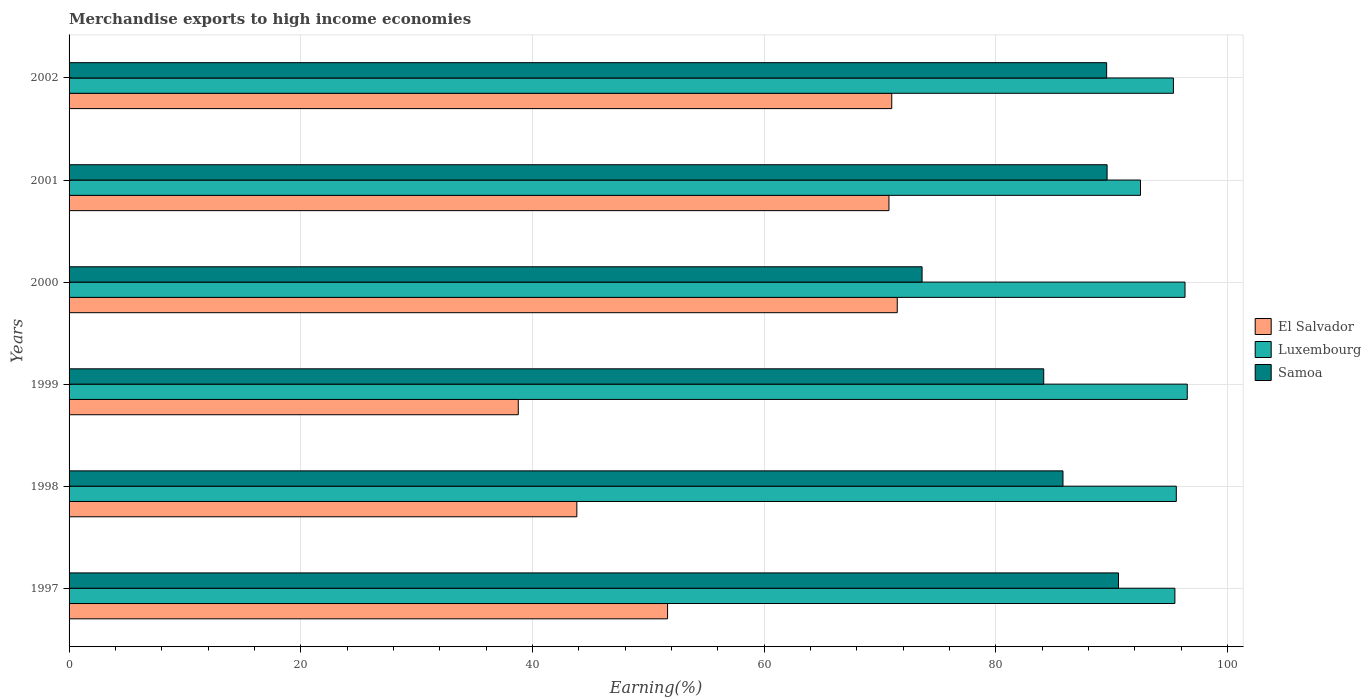How many different coloured bars are there?
Give a very brief answer. 3. How many groups of bars are there?
Your answer should be very brief. 6. Are the number of bars per tick equal to the number of legend labels?
Ensure brevity in your answer.  Yes. How many bars are there on the 3rd tick from the top?
Ensure brevity in your answer.  3. How many bars are there on the 3rd tick from the bottom?
Your answer should be compact. 3. In how many cases, is the number of bars for a given year not equal to the number of legend labels?
Ensure brevity in your answer.  0. What is the percentage of amount earned from merchandise exports in El Salvador in 2001?
Keep it short and to the point. 70.76. Across all years, what is the maximum percentage of amount earned from merchandise exports in Samoa?
Your answer should be very brief. 90.58. Across all years, what is the minimum percentage of amount earned from merchandise exports in Samoa?
Offer a terse response. 73.62. What is the total percentage of amount earned from merchandise exports in Luxembourg in the graph?
Your answer should be compact. 571.63. What is the difference between the percentage of amount earned from merchandise exports in Samoa in 2000 and that in 2001?
Offer a terse response. -15.97. What is the difference between the percentage of amount earned from merchandise exports in Luxembourg in 1998 and the percentage of amount earned from merchandise exports in El Salvador in 2001?
Ensure brevity in your answer.  24.8. What is the average percentage of amount earned from merchandise exports in El Salvador per year?
Offer a very short reply. 57.92. In the year 2001, what is the difference between the percentage of amount earned from merchandise exports in Samoa and percentage of amount earned from merchandise exports in El Salvador?
Offer a terse response. 18.83. In how many years, is the percentage of amount earned from merchandise exports in Luxembourg greater than 76 %?
Ensure brevity in your answer.  6. What is the ratio of the percentage of amount earned from merchandise exports in El Salvador in 1997 to that in 2000?
Provide a short and direct response. 0.72. Is the percentage of amount earned from merchandise exports in El Salvador in 2001 less than that in 2002?
Give a very brief answer. Yes. What is the difference between the highest and the second highest percentage of amount earned from merchandise exports in Samoa?
Ensure brevity in your answer.  0.98. What is the difference between the highest and the lowest percentage of amount earned from merchandise exports in Samoa?
Your answer should be compact. 16.95. In how many years, is the percentage of amount earned from merchandise exports in Luxembourg greater than the average percentage of amount earned from merchandise exports in Luxembourg taken over all years?
Offer a very short reply. 5. Is the sum of the percentage of amount earned from merchandise exports in Luxembourg in 1998 and 1999 greater than the maximum percentage of amount earned from merchandise exports in El Salvador across all years?
Give a very brief answer. Yes. What does the 1st bar from the top in 1999 represents?
Your answer should be compact. Samoa. What does the 1st bar from the bottom in 2000 represents?
Offer a very short reply. El Salvador. Is it the case that in every year, the sum of the percentage of amount earned from merchandise exports in Luxembourg and percentage of amount earned from merchandise exports in El Salvador is greater than the percentage of amount earned from merchandise exports in Samoa?
Your answer should be compact. Yes. How many bars are there?
Offer a very short reply. 18. How many years are there in the graph?
Give a very brief answer. 6. What is the difference between two consecutive major ticks on the X-axis?
Your answer should be compact. 20. Where does the legend appear in the graph?
Provide a succinct answer. Center right. How are the legend labels stacked?
Ensure brevity in your answer.  Vertical. What is the title of the graph?
Make the answer very short. Merchandise exports to high income economies. Does "Montenegro" appear as one of the legend labels in the graph?
Give a very brief answer. No. What is the label or title of the X-axis?
Offer a terse response. Earning(%). What is the Earning(%) of El Salvador in 1997?
Offer a very short reply. 51.66. What is the Earning(%) of Luxembourg in 1997?
Your response must be concise. 95.44. What is the Earning(%) of Samoa in 1997?
Give a very brief answer. 90.58. What is the Earning(%) in El Salvador in 1998?
Ensure brevity in your answer.  43.83. What is the Earning(%) of Luxembourg in 1998?
Ensure brevity in your answer.  95.57. What is the Earning(%) of Samoa in 1998?
Make the answer very short. 85.79. What is the Earning(%) of El Salvador in 1999?
Offer a terse response. 38.77. What is the Earning(%) of Luxembourg in 1999?
Provide a short and direct response. 96.51. What is the Earning(%) in Samoa in 1999?
Your response must be concise. 84.12. What is the Earning(%) of El Salvador in 2000?
Ensure brevity in your answer.  71.48. What is the Earning(%) in Luxembourg in 2000?
Your answer should be compact. 96.32. What is the Earning(%) in Samoa in 2000?
Ensure brevity in your answer.  73.62. What is the Earning(%) of El Salvador in 2001?
Provide a succinct answer. 70.76. What is the Earning(%) of Luxembourg in 2001?
Your answer should be very brief. 92.48. What is the Earning(%) of Samoa in 2001?
Provide a succinct answer. 89.59. What is the Earning(%) of El Salvador in 2002?
Ensure brevity in your answer.  71.01. What is the Earning(%) in Luxembourg in 2002?
Ensure brevity in your answer.  95.32. What is the Earning(%) of Samoa in 2002?
Give a very brief answer. 89.55. Across all years, what is the maximum Earning(%) of El Salvador?
Provide a succinct answer. 71.48. Across all years, what is the maximum Earning(%) of Luxembourg?
Keep it short and to the point. 96.51. Across all years, what is the maximum Earning(%) of Samoa?
Keep it short and to the point. 90.58. Across all years, what is the minimum Earning(%) of El Salvador?
Ensure brevity in your answer.  38.77. Across all years, what is the minimum Earning(%) in Luxembourg?
Provide a succinct answer. 92.48. Across all years, what is the minimum Earning(%) of Samoa?
Your answer should be very brief. 73.62. What is the total Earning(%) of El Salvador in the graph?
Provide a short and direct response. 347.51. What is the total Earning(%) in Luxembourg in the graph?
Your answer should be very brief. 571.63. What is the total Earning(%) of Samoa in the graph?
Your answer should be compact. 513.25. What is the difference between the Earning(%) in El Salvador in 1997 and that in 1998?
Give a very brief answer. 7.83. What is the difference between the Earning(%) in Luxembourg in 1997 and that in 1998?
Ensure brevity in your answer.  -0.12. What is the difference between the Earning(%) in Samoa in 1997 and that in 1998?
Make the answer very short. 4.79. What is the difference between the Earning(%) in El Salvador in 1997 and that in 1999?
Your answer should be compact. 12.89. What is the difference between the Earning(%) in Luxembourg in 1997 and that in 1999?
Offer a very short reply. -1.07. What is the difference between the Earning(%) in Samoa in 1997 and that in 1999?
Keep it short and to the point. 6.45. What is the difference between the Earning(%) in El Salvador in 1997 and that in 2000?
Give a very brief answer. -19.82. What is the difference between the Earning(%) in Luxembourg in 1997 and that in 2000?
Your response must be concise. -0.87. What is the difference between the Earning(%) in Samoa in 1997 and that in 2000?
Keep it short and to the point. 16.95. What is the difference between the Earning(%) of El Salvador in 1997 and that in 2001?
Provide a short and direct response. -19.11. What is the difference between the Earning(%) of Luxembourg in 1997 and that in 2001?
Give a very brief answer. 2.97. What is the difference between the Earning(%) of Samoa in 1997 and that in 2001?
Provide a succinct answer. 0.98. What is the difference between the Earning(%) in El Salvador in 1997 and that in 2002?
Provide a short and direct response. -19.35. What is the difference between the Earning(%) of Luxembourg in 1997 and that in 2002?
Your answer should be compact. 0.13. What is the difference between the Earning(%) of El Salvador in 1998 and that in 1999?
Provide a short and direct response. 5.05. What is the difference between the Earning(%) in Luxembourg in 1998 and that in 1999?
Your response must be concise. -0.95. What is the difference between the Earning(%) in Samoa in 1998 and that in 1999?
Ensure brevity in your answer.  1.66. What is the difference between the Earning(%) in El Salvador in 1998 and that in 2000?
Your answer should be compact. -27.65. What is the difference between the Earning(%) of Luxembourg in 1998 and that in 2000?
Offer a terse response. -0.75. What is the difference between the Earning(%) of Samoa in 1998 and that in 2000?
Your answer should be compact. 12.16. What is the difference between the Earning(%) in El Salvador in 1998 and that in 2001?
Provide a short and direct response. -26.94. What is the difference between the Earning(%) in Luxembourg in 1998 and that in 2001?
Your answer should be very brief. 3.09. What is the difference between the Earning(%) in Samoa in 1998 and that in 2001?
Provide a succinct answer. -3.81. What is the difference between the Earning(%) of El Salvador in 1998 and that in 2002?
Provide a short and direct response. -27.18. What is the difference between the Earning(%) of Luxembourg in 1998 and that in 2002?
Provide a short and direct response. 0.25. What is the difference between the Earning(%) in Samoa in 1998 and that in 2002?
Your answer should be very brief. -3.77. What is the difference between the Earning(%) of El Salvador in 1999 and that in 2000?
Your response must be concise. -32.71. What is the difference between the Earning(%) of Luxembourg in 1999 and that in 2000?
Provide a short and direct response. 0.19. What is the difference between the Earning(%) in Samoa in 1999 and that in 2000?
Your response must be concise. 10.5. What is the difference between the Earning(%) in El Salvador in 1999 and that in 2001?
Offer a terse response. -31.99. What is the difference between the Earning(%) of Luxembourg in 1999 and that in 2001?
Your answer should be compact. 4.04. What is the difference between the Earning(%) of Samoa in 1999 and that in 2001?
Offer a terse response. -5.47. What is the difference between the Earning(%) of El Salvador in 1999 and that in 2002?
Give a very brief answer. -32.23. What is the difference between the Earning(%) in Luxembourg in 1999 and that in 2002?
Offer a terse response. 1.2. What is the difference between the Earning(%) in Samoa in 1999 and that in 2002?
Offer a very short reply. -5.43. What is the difference between the Earning(%) in El Salvador in 2000 and that in 2001?
Offer a terse response. 0.72. What is the difference between the Earning(%) of Luxembourg in 2000 and that in 2001?
Your response must be concise. 3.84. What is the difference between the Earning(%) in Samoa in 2000 and that in 2001?
Keep it short and to the point. -15.97. What is the difference between the Earning(%) of El Salvador in 2000 and that in 2002?
Your answer should be very brief. 0.47. What is the difference between the Earning(%) of Samoa in 2000 and that in 2002?
Give a very brief answer. -15.93. What is the difference between the Earning(%) in El Salvador in 2001 and that in 2002?
Ensure brevity in your answer.  -0.24. What is the difference between the Earning(%) of Luxembourg in 2001 and that in 2002?
Offer a very short reply. -2.84. What is the difference between the Earning(%) in Samoa in 2001 and that in 2002?
Your answer should be compact. 0.04. What is the difference between the Earning(%) of El Salvador in 1997 and the Earning(%) of Luxembourg in 1998?
Your answer should be compact. -43.91. What is the difference between the Earning(%) in El Salvador in 1997 and the Earning(%) in Samoa in 1998?
Give a very brief answer. -34.13. What is the difference between the Earning(%) in Luxembourg in 1997 and the Earning(%) in Samoa in 1998?
Provide a succinct answer. 9.66. What is the difference between the Earning(%) in El Salvador in 1997 and the Earning(%) in Luxembourg in 1999?
Provide a short and direct response. -44.86. What is the difference between the Earning(%) of El Salvador in 1997 and the Earning(%) of Samoa in 1999?
Ensure brevity in your answer.  -32.47. What is the difference between the Earning(%) of Luxembourg in 1997 and the Earning(%) of Samoa in 1999?
Your answer should be compact. 11.32. What is the difference between the Earning(%) in El Salvador in 1997 and the Earning(%) in Luxembourg in 2000?
Offer a terse response. -44.66. What is the difference between the Earning(%) of El Salvador in 1997 and the Earning(%) of Samoa in 2000?
Your response must be concise. -21.97. What is the difference between the Earning(%) of Luxembourg in 1997 and the Earning(%) of Samoa in 2000?
Make the answer very short. 21.82. What is the difference between the Earning(%) of El Salvador in 1997 and the Earning(%) of Luxembourg in 2001?
Provide a succinct answer. -40.82. What is the difference between the Earning(%) of El Salvador in 1997 and the Earning(%) of Samoa in 2001?
Provide a succinct answer. -37.94. What is the difference between the Earning(%) of Luxembourg in 1997 and the Earning(%) of Samoa in 2001?
Provide a short and direct response. 5.85. What is the difference between the Earning(%) of El Salvador in 1997 and the Earning(%) of Luxembourg in 2002?
Provide a succinct answer. -43.66. What is the difference between the Earning(%) in El Salvador in 1997 and the Earning(%) in Samoa in 2002?
Make the answer very short. -37.9. What is the difference between the Earning(%) in Luxembourg in 1997 and the Earning(%) in Samoa in 2002?
Keep it short and to the point. 5.89. What is the difference between the Earning(%) in El Salvador in 1998 and the Earning(%) in Luxembourg in 1999?
Offer a very short reply. -52.69. What is the difference between the Earning(%) in El Salvador in 1998 and the Earning(%) in Samoa in 1999?
Offer a very short reply. -40.3. What is the difference between the Earning(%) in Luxembourg in 1998 and the Earning(%) in Samoa in 1999?
Offer a very short reply. 11.44. What is the difference between the Earning(%) of El Salvador in 1998 and the Earning(%) of Luxembourg in 2000?
Your response must be concise. -52.49. What is the difference between the Earning(%) in El Salvador in 1998 and the Earning(%) in Samoa in 2000?
Offer a very short reply. -29.8. What is the difference between the Earning(%) in Luxembourg in 1998 and the Earning(%) in Samoa in 2000?
Ensure brevity in your answer.  21.94. What is the difference between the Earning(%) of El Salvador in 1998 and the Earning(%) of Luxembourg in 2001?
Make the answer very short. -48.65. What is the difference between the Earning(%) of El Salvador in 1998 and the Earning(%) of Samoa in 2001?
Keep it short and to the point. -45.77. What is the difference between the Earning(%) of Luxembourg in 1998 and the Earning(%) of Samoa in 2001?
Keep it short and to the point. 5.97. What is the difference between the Earning(%) of El Salvador in 1998 and the Earning(%) of Luxembourg in 2002?
Provide a short and direct response. -51.49. What is the difference between the Earning(%) of El Salvador in 1998 and the Earning(%) of Samoa in 2002?
Ensure brevity in your answer.  -45.73. What is the difference between the Earning(%) in Luxembourg in 1998 and the Earning(%) in Samoa in 2002?
Make the answer very short. 6.01. What is the difference between the Earning(%) of El Salvador in 1999 and the Earning(%) of Luxembourg in 2000?
Offer a very short reply. -57.55. What is the difference between the Earning(%) of El Salvador in 1999 and the Earning(%) of Samoa in 2000?
Your answer should be very brief. -34.85. What is the difference between the Earning(%) of Luxembourg in 1999 and the Earning(%) of Samoa in 2000?
Make the answer very short. 22.89. What is the difference between the Earning(%) in El Salvador in 1999 and the Earning(%) in Luxembourg in 2001?
Offer a terse response. -53.7. What is the difference between the Earning(%) of El Salvador in 1999 and the Earning(%) of Samoa in 2001?
Offer a very short reply. -50.82. What is the difference between the Earning(%) in Luxembourg in 1999 and the Earning(%) in Samoa in 2001?
Ensure brevity in your answer.  6.92. What is the difference between the Earning(%) of El Salvador in 1999 and the Earning(%) of Luxembourg in 2002?
Your response must be concise. -56.55. What is the difference between the Earning(%) in El Salvador in 1999 and the Earning(%) in Samoa in 2002?
Ensure brevity in your answer.  -50.78. What is the difference between the Earning(%) in Luxembourg in 1999 and the Earning(%) in Samoa in 2002?
Offer a terse response. 6.96. What is the difference between the Earning(%) of El Salvador in 2000 and the Earning(%) of Luxembourg in 2001?
Provide a succinct answer. -21. What is the difference between the Earning(%) in El Salvador in 2000 and the Earning(%) in Samoa in 2001?
Provide a short and direct response. -18.11. What is the difference between the Earning(%) of Luxembourg in 2000 and the Earning(%) of Samoa in 2001?
Your response must be concise. 6.73. What is the difference between the Earning(%) of El Salvador in 2000 and the Earning(%) of Luxembourg in 2002?
Make the answer very short. -23.84. What is the difference between the Earning(%) in El Salvador in 2000 and the Earning(%) in Samoa in 2002?
Make the answer very short. -18.07. What is the difference between the Earning(%) in Luxembourg in 2000 and the Earning(%) in Samoa in 2002?
Keep it short and to the point. 6.77. What is the difference between the Earning(%) in El Salvador in 2001 and the Earning(%) in Luxembourg in 2002?
Keep it short and to the point. -24.55. What is the difference between the Earning(%) in El Salvador in 2001 and the Earning(%) in Samoa in 2002?
Your response must be concise. -18.79. What is the difference between the Earning(%) in Luxembourg in 2001 and the Earning(%) in Samoa in 2002?
Offer a very short reply. 2.92. What is the average Earning(%) of El Salvador per year?
Provide a succinct answer. 57.92. What is the average Earning(%) in Luxembourg per year?
Offer a terse response. 95.27. What is the average Earning(%) of Samoa per year?
Give a very brief answer. 85.54. In the year 1997, what is the difference between the Earning(%) of El Salvador and Earning(%) of Luxembourg?
Make the answer very short. -43.79. In the year 1997, what is the difference between the Earning(%) in El Salvador and Earning(%) in Samoa?
Provide a short and direct response. -38.92. In the year 1997, what is the difference between the Earning(%) of Luxembourg and Earning(%) of Samoa?
Ensure brevity in your answer.  4.87. In the year 1998, what is the difference between the Earning(%) in El Salvador and Earning(%) in Luxembourg?
Provide a short and direct response. -51.74. In the year 1998, what is the difference between the Earning(%) of El Salvador and Earning(%) of Samoa?
Provide a short and direct response. -41.96. In the year 1998, what is the difference between the Earning(%) in Luxembourg and Earning(%) in Samoa?
Ensure brevity in your answer.  9.78. In the year 1999, what is the difference between the Earning(%) of El Salvador and Earning(%) of Luxembourg?
Keep it short and to the point. -57.74. In the year 1999, what is the difference between the Earning(%) of El Salvador and Earning(%) of Samoa?
Keep it short and to the point. -45.35. In the year 1999, what is the difference between the Earning(%) of Luxembourg and Earning(%) of Samoa?
Your answer should be very brief. 12.39. In the year 2000, what is the difference between the Earning(%) in El Salvador and Earning(%) in Luxembourg?
Provide a short and direct response. -24.84. In the year 2000, what is the difference between the Earning(%) of El Salvador and Earning(%) of Samoa?
Make the answer very short. -2.14. In the year 2000, what is the difference between the Earning(%) in Luxembourg and Earning(%) in Samoa?
Provide a succinct answer. 22.69. In the year 2001, what is the difference between the Earning(%) of El Salvador and Earning(%) of Luxembourg?
Your response must be concise. -21.71. In the year 2001, what is the difference between the Earning(%) in El Salvador and Earning(%) in Samoa?
Provide a short and direct response. -18.83. In the year 2001, what is the difference between the Earning(%) in Luxembourg and Earning(%) in Samoa?
Keep it short and to the point. 2.88. In the year 2002, what is the difference between the Earning(%) of El Salvador and Earning(%) of Luxembourg?
Make the answer very short. -24.31. In the year 2002, what is the difference between the Earning(%) in El Salvador and Earning(%) in Samoa?
Provide a short and direct response. -18.55. In the year 2002, what is the difference between the Earning(%) of Luxembourg and Earning(%) of Samoa?
Offer a very short reply. 5.76. What is the ratio of the Earning(%) of El Salvador in 1997 to that in 1998?
Your answer should be compact. 1.18. What is the ratio of the Earning(%) of Samoa in 1997 to that in 1998?
Ensure brevity in your answer.  1.06. What is the ratio of the Earning(%) in El Salvador in 1997 to that in 1999?
Ensure brevity in your answer.  1.33. What is the ratio of the Earning(%) in Luxembourg in 1997 to that in 1999?
Keep it short and to the point. 0.99. What is the ratio of the Earning(%) in Samoa in 1997 to that in 1999?
Keep it short and to the point. 1.08. What is the ratio of the Earning(%) of El Salvador in 1997 to that in 2000?
Ensure brevity in your answer.  0.72. What is the ratio of the Earning(%) in Luxembourg in 1997 to that in 2000?
Offer a terse response. 0.99. What is the ratio of the Earning(%) in Samoa in 1997 to that in 2000?
Give a very brief answer. 1.23. What is the ratio of the Earning(%) in El Salvador in 1997 to that in 2001?
Provide a short and direct response. 0.73. What is the ratio of the Earning(%) in Luxembourg in 1997 to that in 2001?
Make the answer very short. 1.03. What is the ratio of the Earning(%) in Samoa in 1997 to that in 2001?
Offer a very short reply. 1.01. What is the ratio of the Earning(%) in El Salvador in 1997 to that in 2002?
Keep it short and to the point. 0.73. What is the ratio of the Earning(%) of Luxembourg in 1997 to that in 2002?
Make the answer very short. 1. What is the ratio of the Earning(%) of Samoa in 1997 to that in 2002?
Give a very brief answer. 1.01. What is the ratio of the Earning(%) of El Salvador in 1998 to that in 1999?
Your response must be concise. 1.13. What is the ratio of the Earning(%) of Luxembourg in 1998 to that in 1999?
Provide a succinct answer. 0.99. What is the ratio of the Earning(%) in Samoa in 1998 to that in 1999?
Make the answer very short. 1.02. What is the ratio of the Earning(%) in El Salvador in 1998 to that in 2000?
Provide a short and direct response. 0.61. What is the ratio of the Earning(%) in Luxembourg in 1998 to that in 2000?
Keep it short and to the point. 0.99. What is the ratio of the Earning(%) in Samoa in 1998 to that in 2000?
Your response must be concise. 1.17. What is the ratio of the Earning(%) in El Salvador in 1998 to that in 2001?
Provide a short and direct response. 0.62. What is the ratio of the Earning(%) of Luxembourg in 1998 to that in 2001?
Offer a very short reply. 1.03. What is the ratio of the Earning(%) of Samoa in 1998 to that in 2001?
Provide a succinct answer. 0.96. What is the ratio of the Earning(%) in El Salvador in 1998 to that in 2002?
Give a very brief answer. 0.62. What is the ratio of the Earning(%) of Samoa in 1998 to that in 2002?
Ensure brevity in your answer.  0.96. What is the ratio of the Earning(%) of El Salvador in 1999 to that in 2000?
Make the answer very short. 0.54. What is the ratio of the Earning(%) of Samoa in 1999 to that in 2000?
Your response must be concise. 1.14. What is the ratio of the Earning(%) in El Salvador in 1999 to that in 2001?
Your answer should be very brief. 0.55. What is the ratio of the Earning(%) in Luxembourg in 1999 to that in 2001?
Ensure brevity in your answer.  1.04. What is the ratio of the Earning(%) in Samoa in 1999 to that in 2001?
Keep it short and to the point. 0.94. What is the ratio of the Earning(%) of El Salvador in 1999 to that in 2002?
Give a very brief answer. 0.55. What is the ratio of the Earning(%) of Luxembourg in 1999 to that in 2002?
Your answer should be very brief. 1.01. What is the ratio of the Earning(%) of Samoa in 1999 to that in 2002?
Offer a terse response. 0.94. What is the ratio of the Earning(%) in El Salvador in 2000 to that in 2001?
Offer a terse response. 1.01. What is the ratio of the Earning(%) of Luxembourg in 2000 to that in 2001?
Keep it short and to the point. 1.04. What is the ratio of the Earning(%) in Samoa in 2000 to that in 2001?
Make the answer very short. 0.82. What is the ratio of the Earning(%) of Luxembourg in 2000 to that in 2002?
Your response must be concise. 1.01. What is the ratio of the Earning(%) of Samoa in 2000 to that in 2002?
Keep it short and to the point. 0.82. What is the ratio of the Earning(%) in Luxembourg in 2001 to that in 2002?
Provide a succinct answer. 0.97. What is the difference between the highest and the second highest Earning(%) of El Salvador?
Provide a succinct answer. 0.47. What is the difference between the highest and the second highest Earning(%) of Luxembourg?
Give a very brief answer. 0.19. What is the difference between the highest and the second highest Earning(%) in Samoa?
Your response must be concise. 0.98. What is the difference between the highest and the lowest Earning(%) in El Salvador?
Your answer should be compact. 32.71. What is the difference between the highest and the lowest Earning(%) of Luxembourg?
Offer a terse response. 4.04. What is the difference between the highest and the lowest Earning(%) in Samoa?
Give a very brief answer. 16.95. 